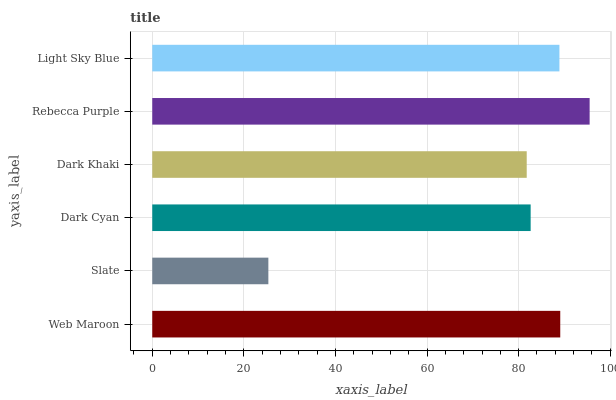Is Slate the minimum?
Answer yes or no. Yes. Is Rebecca Purple the maximum?
Answer yes or no. Yes. Is Dark Cyan the minimum?
Answer yes or no. No. Is Dark Cyan the maximum?
Answer yes or no. No. Is Dark Cyan greater than Slate?
Answer yes or no. Yes. Is Slate less than Dark Cyan?
Answer yes or no. Yes. Is Slate greater than Dark Cyan?
Answer yes or no. No. Is Dark Cyan less than Slate?
Answer yes or no. No. Is Light Sky Blue the high median?
Answer yes or no. Yes. Is Dark Cyan the low median?
Answer yes or no. Yes. Is Rebecca Purple the high median?
Answer yes or no. No. Is Web Maroon the low median?
Answer yes or no. No. 